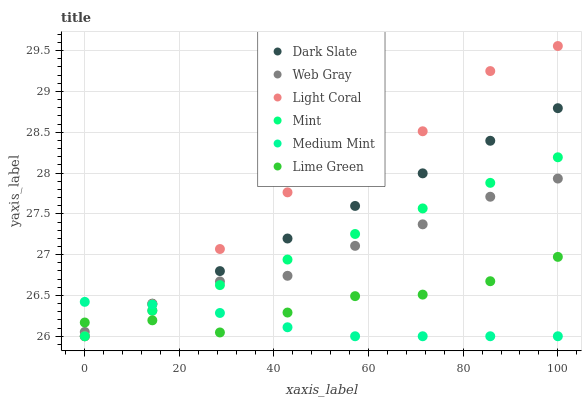Does Medium Mint have the minimum area under the curve?
Answer yes or no. Yes. Does Light Coral have the maximum area under the curve?
Answer yes or no. Yes. Does Web Gray have the minimum area under the curve?
Answer yes or no. No. Does Web Gray have the maximum area under the curve?
Answer yes or no. No. Is Dark Slate the smoothest?
Answer yes or no. Yes. Is Light Coral the roughest?
Answer yes or no. Yes. Is Web Gray the smoothest?
Answer yes or no. No. Is Web Gray the roughest?
Answer yes or no. No. Does Medium Mint have the lowest value?
Answer yes or no. Yes. Does Lime Green have the lowest value?
Answer yes or no. No. Does Light Coral have the highest value?
Answer yes or no. Yes. Does Web Gray have the highest value?
Answer yes or no. No. Does Dark Slate intersect Medium Mint?
Answer yes or no. Yes. Is Dark Slate less than Medium Mint?
Answer yes or no. No. Is Dark Slate greater than Medium Mint?
Answer yes or no. No. 